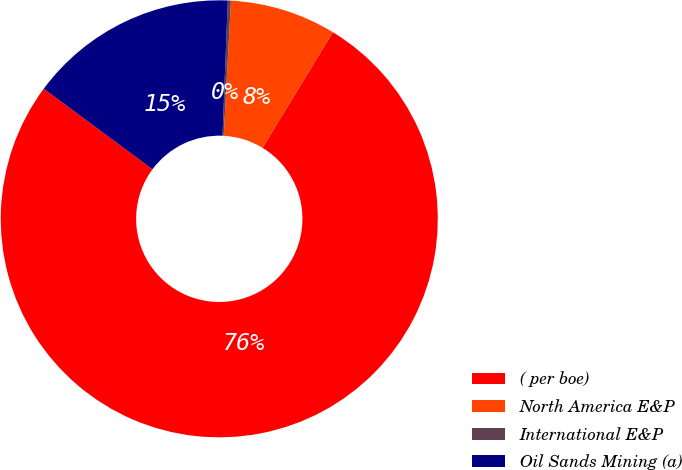Convert chart. <chart><loc_0><loc_0><loc_500><loc_500><pie_chart><fcel>( per boe)<fcel>North America E&P<fcel>International E&P<fcel>Oil Sands Mining (a)<nl><fcel>76.45%<fcel>7.85%<fcel>0.23%<fcel>15.47%<nl></chart> 